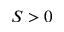Convert formula to latex. <formula><loc_0><loc_0><loc_500><loc_500>S > 0</formula> 